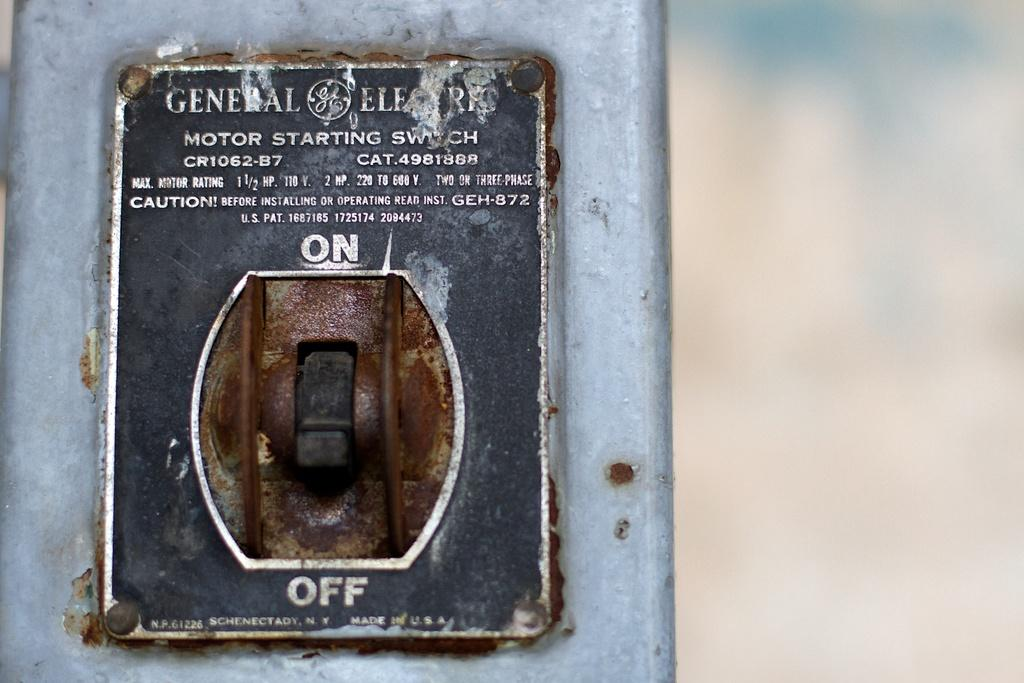<image>
Write a terse but informative summary of the picture. An extremely old looking switch with on at the top and off at the bottom 